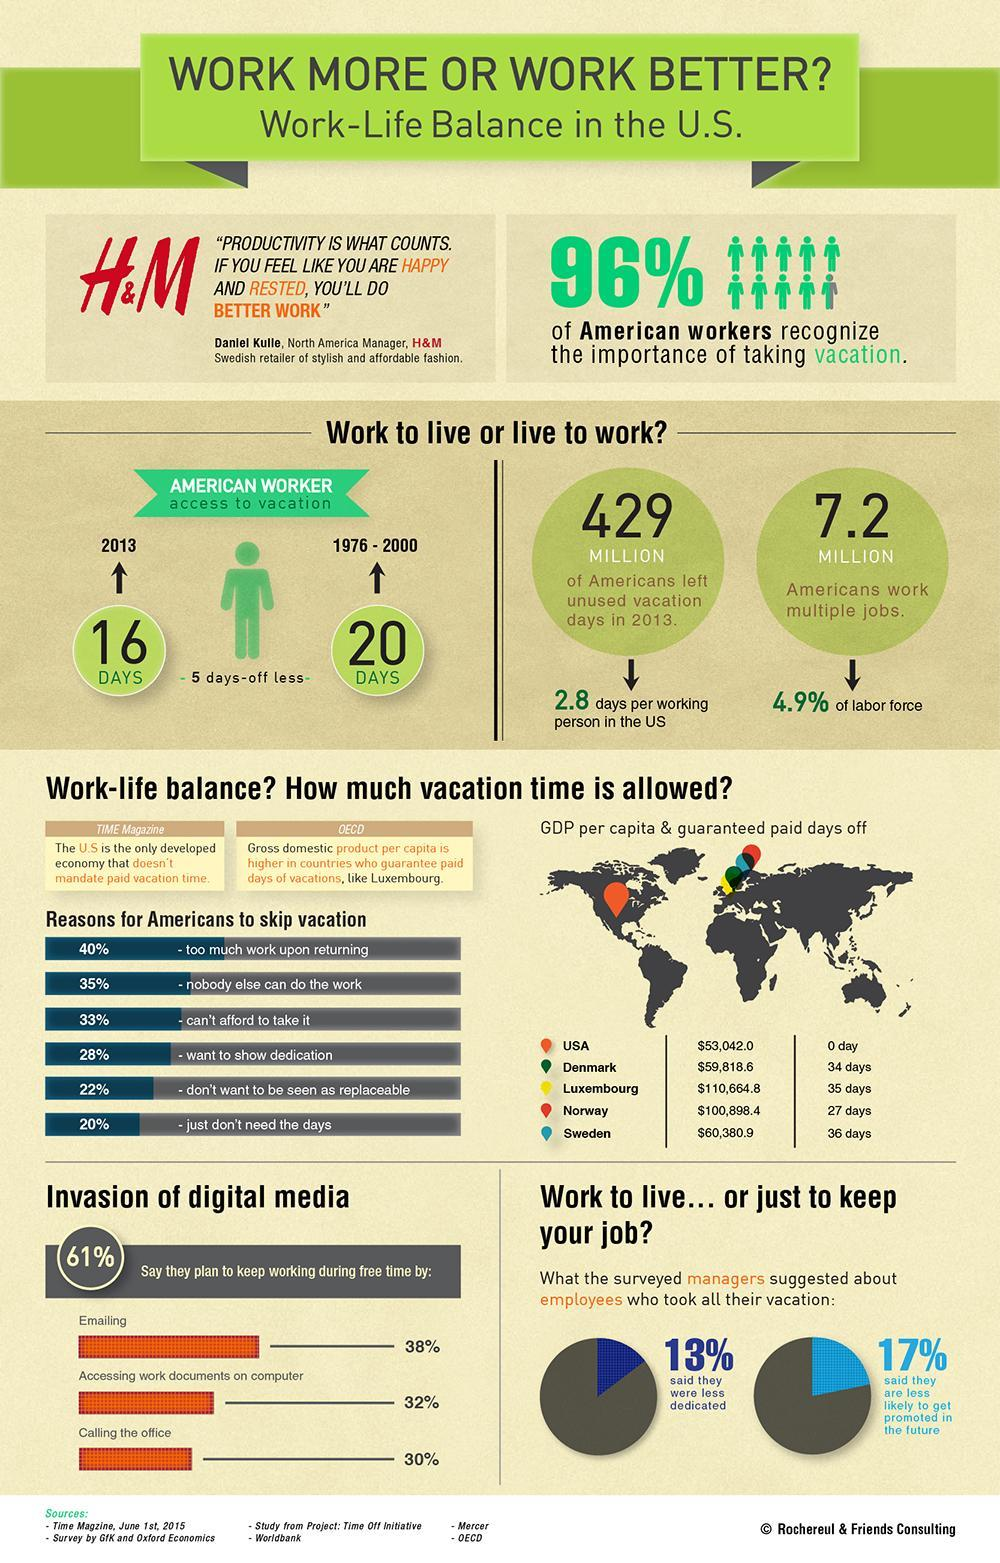How many days of vacation were taken by American workers in 2013?
Answer the question with a short phrase. 16 Days What is the american population that left unused vacation days in 2013? 429 MIION What percent of americans recognize the importance of taking vacation? 96% How many days of vacation were taken by American workers during 1976-2000? 20 What is the american population that works for multiple jobs? 7.2 MILLION What percent of Americans skip vacation due to work pressure after returning? 40% 